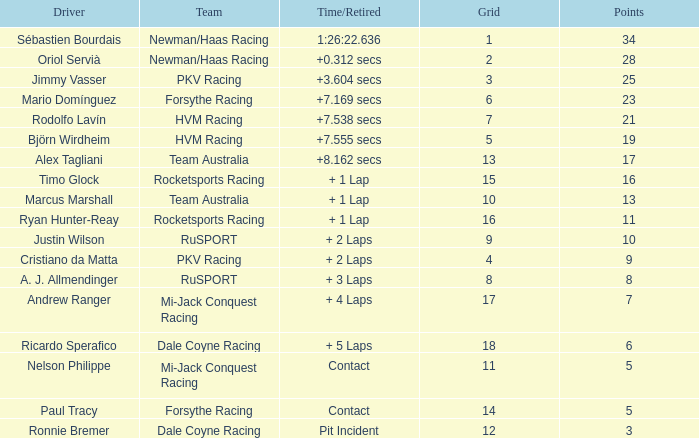What are the typical laps for driver ricardo sperafico? 161.0. 